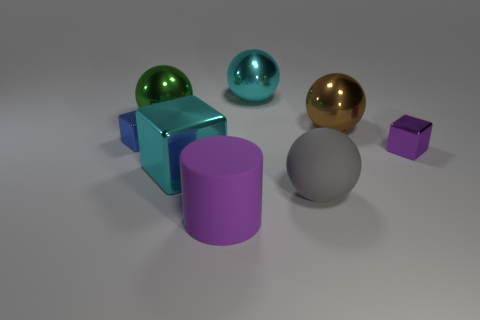What is the shape of the thing that is both in front of the blue metallic thing and on the left side of the big purple rubber thing?
Provide a short and direct response. Cube. Are there fewer small brown cubes than large gray rubber things?
Provide a succinct answer. Yes. Are any large cyan matte cubes visible?
Your answer should be compact. No. How many other objects are there of the same size as the gray rubber sphere?
Your answer should be very brief. 5. Is the material of the cyan block the same as the tiny cube on the left side of the small purple cube?
Provide a succinct answer. Yes. Is the number of small purple blocks that are to the left of the tiny blue block the same as the number of brown metal objects in front of the matte cylinder?
Make the answer very short. Yes. What is the blue object made of?
Give a very brief answer. Metal. There is a matte thing that is the same size as the purple cylinder; what is its color?
Your answer should be compact. Gray. Are there any small purple shiny objects behind the metallic object on the right side of the large brown object?
Your answer should be compact. No. How many cylinders are tiny purple metallic objects or big metallic objects?
Provide a succinct answer. 0. 